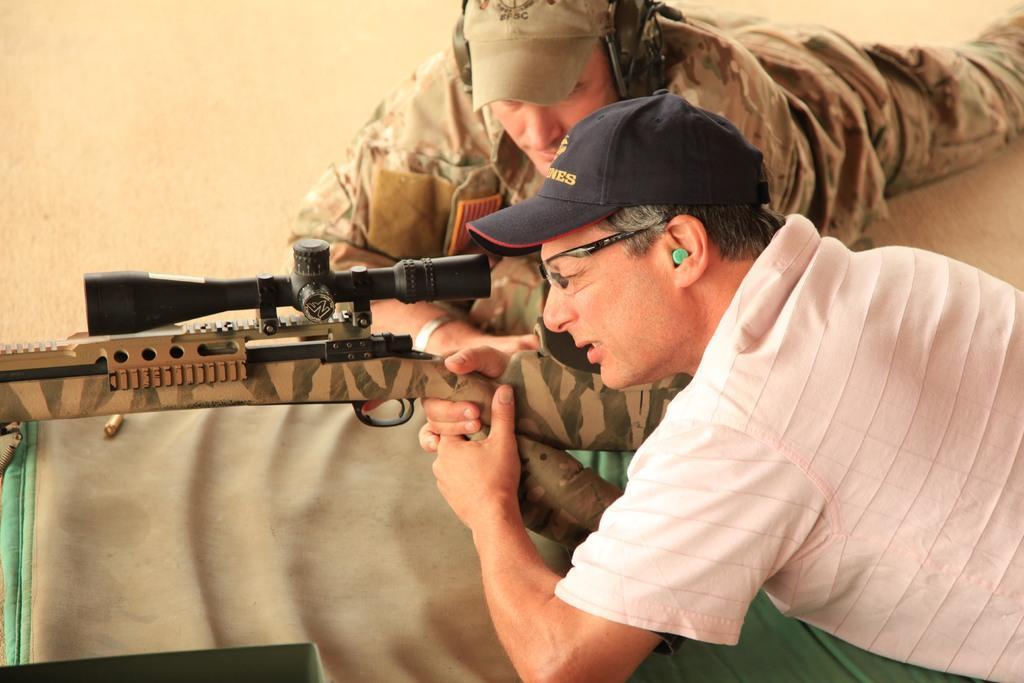How would you summarize this image in a sentence or two? In this image, we can see persons wearing clothes and caps. There is a person on the right side of the image holding a gun with hands. There is a cloth at the bottom of the image. 